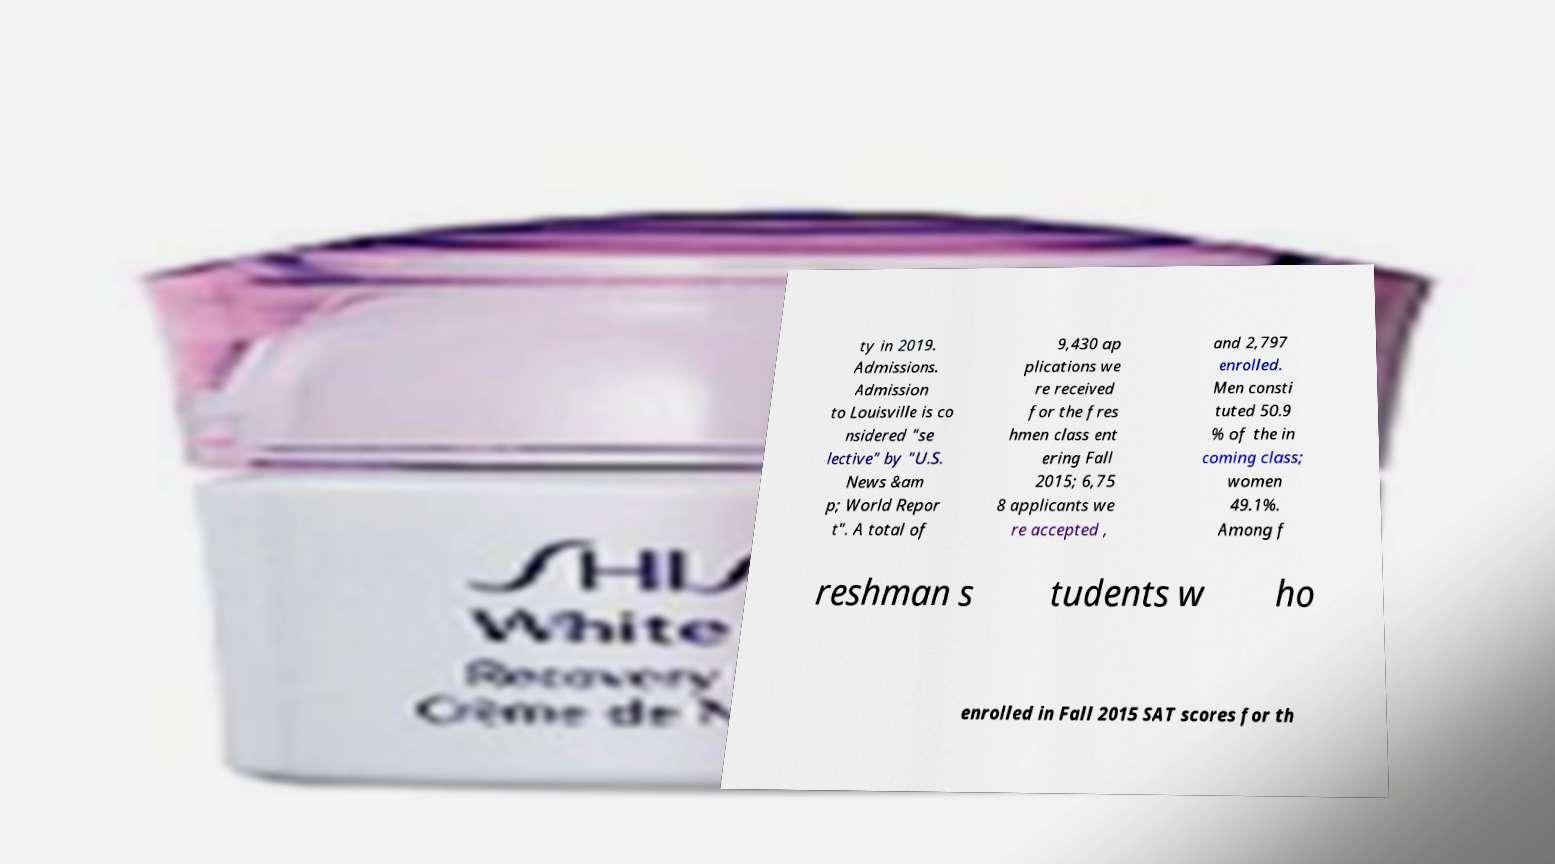Can you read and provide the text displayed in the image?This photo seems to have some interesting text. Can you extract and type it out for me? ty in 2019. Admissions. Admission to Louisville is co nsidered "se lective" by "U.S. News &am p; World Repor t". A total of 9,430 ap plications we re received for the fres hmen class ent ering Fall 2015; 6,75 8 applicants we re accepted , and 2,797 enrolled. Men consti tuted 50.9 % of the in coming class; women 49.1%. Among f reshman s tudents w ho enrolled in Fall 2015 SAT scores for th 